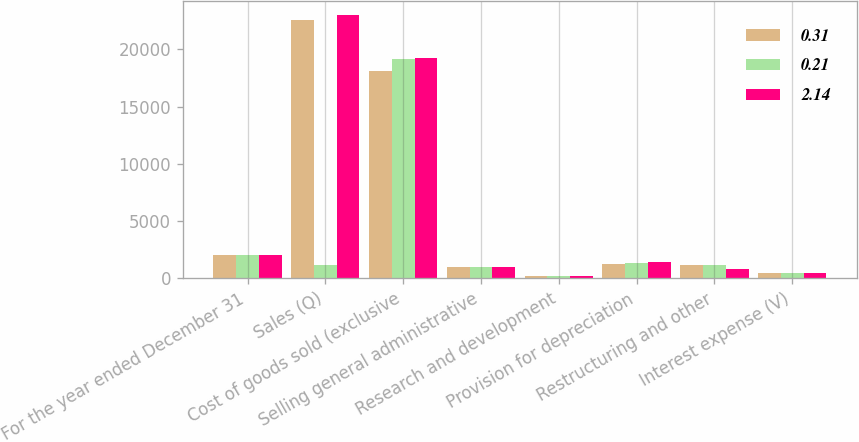Convert chart to OTSL. <chart><loc_0><loc_0><loc_500><loc_500><stacked_bar_chart><ecel><fcel>For the year ended December 31<fcel>Sales (Q)<fcel>Cost of goods sold (exclusive<fcel>Selling general administrative<fcel>Research and development<fcel>Provision for depreciation<fcel>Restructuring and other<fcel>Interest expense (V)<nl><fcel>0.31<fcel>2015<fcel>22534<fcel>18069<fcel>979<fcel>238<fcel>1280<fcel>1195<fcel>498<nl><fcel>0.21<fcel>2014<fcel>1195<fcel>19137<fcel>995<fcel>218<fcel>1371<fcel>1168<fcel>473<nl><fcel>2.14<fcel>2013<fcel>23032<fcel>19286<fcel>1008<fcel>192<fcel>1421<fcel>782<fcel>453<nl></chart> 